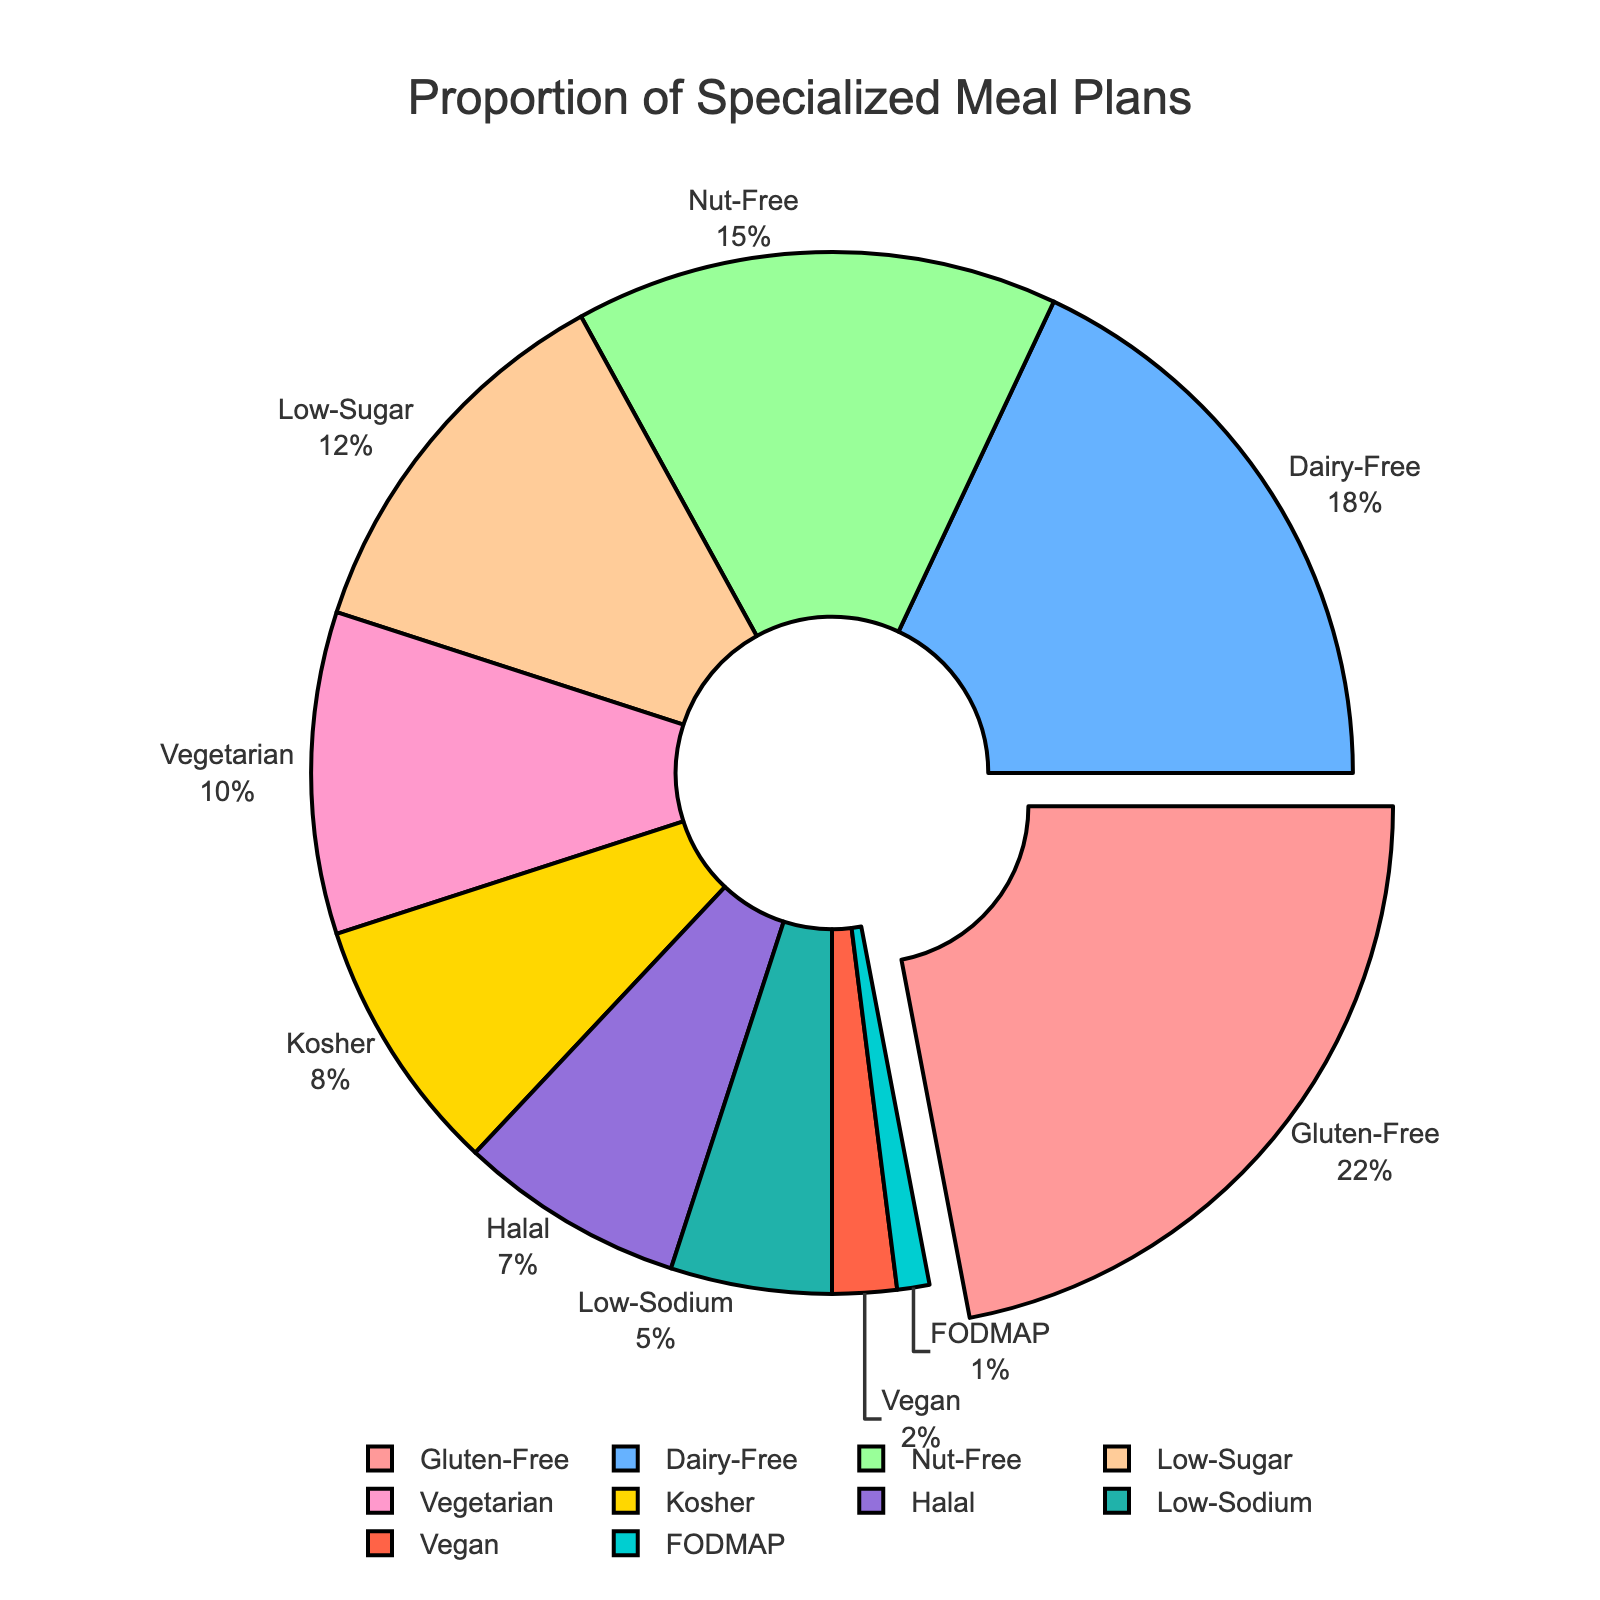What is the most common specialized meal plan provided by the school? The most common meal plan is the one with the largest percentage slice in the pie. By looking at the figure, the largest slice represents the gluten-free meal plan with 22%.
Answer: Gluten-Free Which meal plan has the smallest proportion? The smallest slice in the pie chart represents the meal plan with the smallest proportion. The smallest slice corresponds to the FODMAP meal plan with 1%.
Answer: FODMAP How much larger is the proportion of Gluten-Free meal plans compared to Vegan meal plans? First, identify the proportions: Gluten-Free has 22% and Vegan has 2%. Then subtract the Vegan proportion from the Gluten-Free proportion: 22% - 2% = 20%.
Answer: 20% What is the combined percentage of Dairy-Free and Nut-Free meal plans? Add the percentages of Dairy-Free (18%) and Nut-Free (15%): 18% + 15% = 33%.
Answer: 33% Which meal plan types together constitute more than half the total meal plans provided? Add the percentages of the most common meal plans until the sum exceeds 50%. Gluten-Free (22%) + Dairy-Free (18%) + Nut-Free (15%) = 55%, which is more than half.
Answer: Gluten-Free, Dairy-Free, Nut-Free Is the proportion of Halal meal plans greater than that of Kosher meal plans? Compare the percentages: Halal has 7% and Kosher has 8%. Since 7% is less than 8%, the proportion of Halal meal plans is not greater.
Answer: No What percentage of meal plans are Vegetarian and Vegan combined? Add the percentages of Vegetarian (10%) and Vegan (2%): 10% + 2% = 12%.
Answer: 12% Which meal plan has a slightly larger proportion: Low-Sodium or Vegan? Compare the percentages: Low-Sodium has 5% and Vegan has 2%. Since 5% is greater than 2%, Low-Sodium has a larger proportion.
Answer: Low-Sodium What is the difference in proportion between Low-Sugar and FODMAP meal plans? Subtract the FODMAP proportion from the Low-Sugar proportion: 12% - 1% = 11%.
Answer: 11% What is the second most common meal plan provided? Identify the second largest slice, which corresponds to the Dairy-Free meal plan with 18%.
Answer: Dairy-Free 